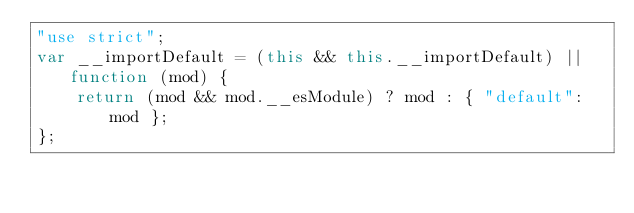Convert code to text. <code><loc_0><loc_0><loc_500><loc_500><_JavaScript_>"use strict";
var __importDefault = (this && this.__importDefault) || function (mod) {
    return (mod && mod.__esModule) ? mod : { "default": mod };
};</code> 